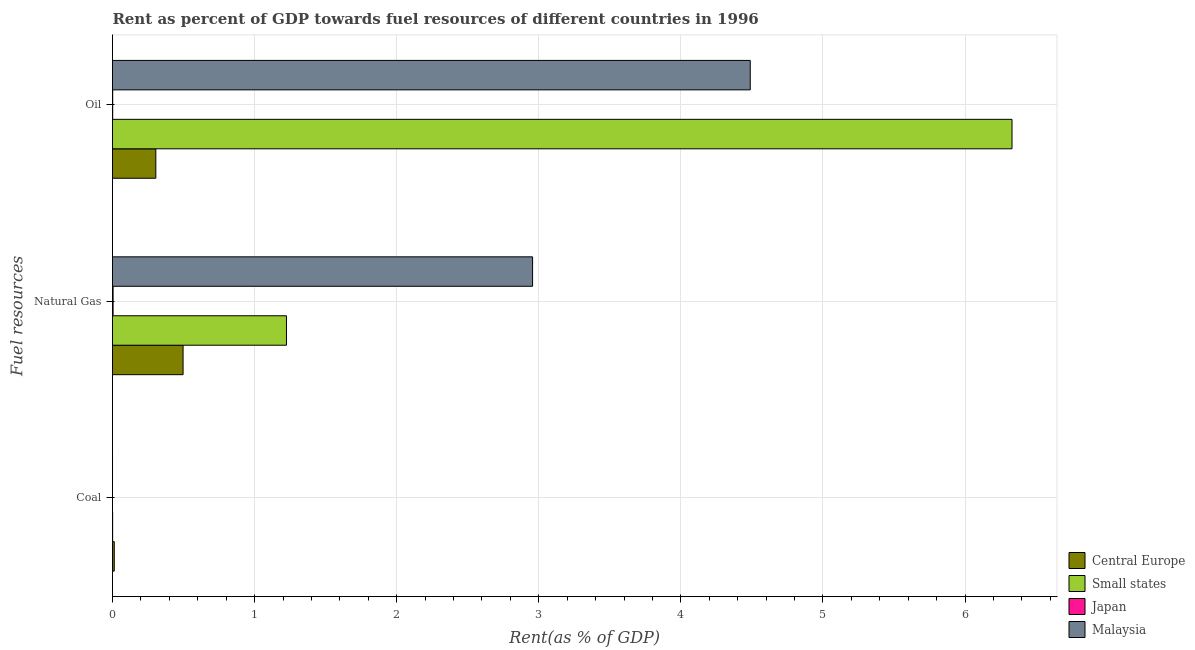How many different coloured bars are there?
Offer a very short reply. 4. How many groups of bars are there?
Provide a short and direct response. 3. Are the number of bars per tick equal to the number of legend labels?
Offer a very short reply. Yes. What is the label of the 2nd group of bars from the top?
Keep it short and to the point. Natural Gas. What is the rent towards natural gas in Japan?
Make the answer very short. 0. Across all countries, what is the maximum rent towards coal?
Your answer should be very brief. 0.01. Across all countries, what is the minimum rent towards coal?
Your response must be concise. 5.59419747539997e-7. In which country was the rent towards natural gas maximum?
Your answer should be very brief. Malaysia. What is the total rent towards oil in the graph?
Your answer should be compact. 11.13. What is the difference between the rent towards oil in Central Europe and that in Malaysia?
Keep it short and to the point. -4.18. What is the difference between the rent towards oil in Small states and the rent towards natural gas in Malaysia?
Offer a terse response. 3.37. What is the average rent towards natural gas per country?
Your answer should be very brief. 1.17. What is the difference between the rent towards coal and rent towards oil in Japan?
Offer a very short reply. -0. In how many countries, is the rent towards natural gas greater than 0.4 %?
Your answer should be very brief. 3. What is the ratio of the rent towards natural gas in Japan to that in Small states?
Provide a succinct answer. 0. What is the difference between the highest and the second highest rent towards natural gas?
Offer a terse response. 1.73. What is the difference between the highest and the lowest rent towards coal?
Provide a succinct answer. 0.01. What does the 3rd bar from the top in Natural Gas represents?
Your answer should be very brief. Small states. What does the 4th bar from the bottom in Natural Gas represents?
Give a very brief answer. Malaysia. How many countries are there in the graph?
Give a very brief answer. 4. Does the graph contain grids?
Make the answer very short. Yes. How many legend labels are there?
Your answer should be very brief. 4. What is the title of the graph?
Ensure brevity in your answer.  Rent as percent of GDP towards fuel resources of different countries in 1996. What is the label or title of the X-axis?
Your response must be concise. Rent(as % of GDP). What is the label or title of the Y-axis?
Ensure brevity in your answer.  Fuel resources. What is the Rent(as % of GDP) of Central Europe in Coal?
Provide a short and direct response. 0.01. What is the Rent(as % of GDP) of Small states in Coal?
Your response must be concise. 0. What is the Rent(as % of GDP) of Japan in Coal?
Ensure brevity in your answer.  5.59419747539997e-7. What is the Rent(as % of GDP) in Malaysia in Coal?
Offer a very short reply. 8.374194379820171e-5. What is the Rent(as % of GDP) in Central Europe in Natural Gas?
Offer a very short reply. 0.5. What is the Rent(as % of GDP) of Small states in Natural Gas?
Provide a short and direct response. 1.22. What is the Rent(as % of GDP) in Japan in Natural Gas?
Keep it short and to the point. 0. What is the Rent(as % of GDP) in Malaysia in Natural Gas?
Provide a succinct answer. 2.96. What is the Rent(as % of GDP) in Central Europe in Oil?
Provide a short and direct response. 0.3. What is the Rent(as % of GDP) of Small states in Oil?
Ensure brevity in your answer.  6.33. What is the Rent(as % of GDP) of Japan in Oil?
Ensure brevity in your answer.  0. What is the Rent(as % of GDP) of Malaysia in Oil?
Your response must be concise. 4.49. Across all Fuel resources, what is the maximum Rent(as % of GDP) in Central Europe?
Your response must be concise. 0.5. Across all Fuel resources, what is the maximum Rent(as % of GDP) of Small states?
Give a very brief answer. 6.33. Across all Fuel resources, what is the maximum Rent(as % of GDP) of Japan?
Offer a terse response. 0. Across all Fuel resources, what is the maximum Rent(as % of GDP) in Malaysia?
Keep it short and to the point. 4.49. Across all Fuel resources, what is the minimum Rent(as % of GDP) of Central Europe?
Keep it short and to the point. 0.01. Across all Fuel resources, what is the minimum Rent(as % of GDP) of Small states?
Give a very brief answer. 0. Across all Fuel resources, what is the minimum Rent(as % of GDP) in Japan?
Provide a short and direct response. 5.59419747539997e-7. Across all Fuel resources, what is the minimum Rent(as % of GDP) in Malaysia?
Give a very brief answer. 8.374194379820171e-5. What is the total Rent(as % of GDP) in Central Europe in the graph?
Ensure brevity in your answer.  0.81. What is the total Rent(as % of GDP) in Small states in the graph?
Give a very brief answer. 7.56. What is the total Rent(as % of GDP) of Japan in the graph?
Provide a short and direct response. 0.01. What is the total Rent(as % of GDP) in Malaysia in the graph?
Offer a terse response. 7.45. What is the difference between the Rent(as % of GDP) of Central Europe in Coal and that in Natural Gas?
Give a very brief answer. -0.48. What is the difference between the Rent(as % of GDP) in Small states in Coal and that in Natural Gas?
Your answer should be compact. -1.22. What is the difference between the Rent(as % of GDP) in Japan in Coal and that in Natural Gas?
Keep it short and to the point. -0. What is the difference between the Rent(as % of GDP) in Malaysia in Coal and that in Natural Gas?
Offer a terse response. -2.96. What is the difference between the Rent(as % of GDP) of Central Europe in Coal and that in Oil?
Keep it short and to the point. -0.29. What is the difference between the Rent(as % of GDP) in Small states in Coal and that in Oil?
Your response must be concise. -6.33. What is the difference between the Rent(as % of GDP) of Japan in Coal and that in Oil?
Ensure brevity in your answer.  -0. What is the difference between the Rent(as % of GDP) of Malaysia in Coal and that in Oil?
Provide a short and direct response. -4.49. What is the difference between the Rent(as % of GDP) in Central Europe in Natural Gas and that in Oil?
Offer a terse response. 0.19. What is the difference between the Rent(as % of GDP) of Small states in Natural Gas and that in Oil?
Offer a terse response. -5.11. What is the difference between the Rent(as % of GDP) of Japan in Natural Gas and that in Oil?
Your response must be concise. 0. What is the difference between the Rent(as % of GDP) of Malaysia in Natural Gas and that in Oil?
Ensure brevity in your answer.  -1.53. What is the difference between the Rent(as % of GDP) in Central Europe in Coal and the Rent(as % of GDP) in Small states in Natural Gas?
Provide a short and direct response. -1.21. What is the difference between the Rent(as % of GDP) of Central Europe in Coal and the Rent(as % of GDP) of Japan in Natural Gas?
Offer a very short reply. 0.01. What is the difference between the Rent(as % of GDP) in Central Europe in Coal and the Rent(as % of GDP) in Malaysia in Natural Gas?
Offer a terse response. -2.94. What is the difference between the Rent(as % of GDP) in Small states in Coal and the Rent(as % of GDP) in Japan in Natural Gas?
Your answer should be very brief. -0. What is the difference between the Rent(as % of GDP) in Small states in Coal and the Rent(as % of GDP) in Malaysia in Natural Gas?
Keep it short and to the point. -2.96. What is the difference between the Rent(as % of GDP) of Japan in Coal and the Rent(as % of GDP) of Malaysia in Natural Gas?
Your answer should be very brief. -2.96. What is the difference between the Rent(as % of GDP) in Central Europe in Coal and the Rent(as % of GDP) in Small states in Oil?
Offer a terse response. -6.32. What is the difference between the Rent(as % of GDP) of Central Europe in Coal and the Rent(as % of GDP) of Japan in Oil?
Make the answer very short. 0.01. What is the difference between the Rent(as % of GDP) of Central Europe in Coal and the Rent(as % of GDP) of Malaysia in Oil?
Provide a succinct answer. -4.48. What is the difference between the Rent(as % of GDP) of Small states in Coal and the Rent(as % of GDP) of Japan in Oil?
Provide a short and direct response. -0. What is the difference between the Rent(as % of GDP) of Small states in Coal and the Rent(as % of GDP) of Malaysia in Oil?
Ensure brevity in your answer.  -4.49. What is the difference between the Rent(as % of GDP) in Japan in Coal and the Rent(as % of GDP) in Malaysia in Oil?
Offer a terse response. -4.49. What is the difference between the Rent(as % of GDP) in Central Europe in Natural Gas and the Rent(as % of GDP) in Small states in Oil?
Provide a succinct answer. -5.83. What is the difference between the Rent(as % of GDP) of Central Europe in Natural Gas and the Rent(as % of GDP) of Japan in Oil?
Make the answer very short. 0.5. What is the difference between the Rent(as % of GDP) of Central Europe in Natural Gas and the Rent(as % of GDP) of Malaysia in Oil?
Provide a succinct answer. -3.99. What is the difference between the Rent(as % of GDP) in Small states in Natural Gas and the Rent(as % of GDP) in Japan in Oil?
Your response must be concise. 1.22. What is the difference between the Rent(as % of GDP) of Small states in Natural Gas and the Rent(as % of GDP) of Malaysia in Oil?
Your response must be concise. -3.26. What is the difference between the Rent(as % of GDP) of Japan in Natural Gas and the Rent(as % of GDP) of Malaysia in Oil?
Give a very brief answer. -4.48. What is the average Rent(as % of GDP) in Central Europe per Fuel resources?
Offer a terse response. 0.27. What is the average Rent(as % of GDP) of Small states per Fuel resources?
Make the answer very short. 2.52. What is the average Rent(as % of GDP) of Japan per Fuel resources?
Your answer should be compact. 0. What is the average Rent(as % of GDP) of Malaysia per Fuel resources?
Your answer should be very brief. 2.48. What is the difference between the Rent(as % of GDP) of Central Europe and Rent(as % of GDP) of Small states in Coal?
Your answer should be very brief. 0.01. What is the difference between the Rent(as % of GDP) of Central Europe and Rent(as % of GDP) of Japan in Coal?
Provide a short and direct response. 0.01. What is the difference between the Rent(as % of GDP) in Central Europe and Rent(as % of GDP) in Malaysia in Coal?
Your answer should be compact. 0.01. What is the difference between the Rent(as % of GDP) in Small states and Rent(as % of GDP) in Japan in Coal?
Keep it short and to the point. 0. What is the difference between the Rent(as % of GDP) in Small states and Rent(as % of GDP) in Malaysia in Coal?
Offer a terse response. 0. What is the difference between the Rent(as % of GDP) in Japan and Rent(as % of GDP) in Malaysia in Coal?
Give a very brief answer. -0. What is the difference between the Rent(as % of GDP) of Central Europe and Rent(as % of GDP) of Small states in Natural Gas?
Your answer should be compact. -0.73. What is the difference between the Rent(as % of GDP) of Central Europe and Rent(as % of GDP) of Japan in Natural Gas?
Offer a very short reply. 0.49. What is the difference between the Rent(as % of GDP) in Central Europe and Rent(as % of GDP) in Malaysia in Natural Gas?
Your answer should be compact. -2.46. What is the difference between the Rent(as % of GDP) in Small states and Rent(as % of GDP) in Japan in Natural Gas?
Offer a very short reply. 1.22. What is the difference between the Rent(as % of GDP) in Small states and Rent(as % of GDP) in Malaysia in Natural Gas?
Provide a succinct answer. -1.73. What is the difference between the Rent(as % of GDP) of Japan and Rent(as % of GDP) of Malaysia in Natural Gas?
Keep it short and to the point. -2.95. What is the difference between the Rent(as % of GDP) of Central Europe and Rent(as % of GDP) of Small states in Oil?
Give a very brief answer. -6.03. What is the difference between the Rent(as % of GDP) of Central Europe and Rent(as % of GDP) of Japan in Oil?
Make the answer very short. 0.3. What is the difference between the Rent(as % of GDP) in Central Europe and Rent(as % of GDP) in Malaysia in Oil?
Your answer should be compact. -4.18. What is the difference between the Rent(as % of GDP) in Small states and Rent(as % of GDP) in Japan in Oil?
Your answer should be compact. 6.33. What is the difference between the Rent(as % of GDP) of Small states and Rent(as % of GDP) of Malaysia in Oil?
Make the answer very short. 1.84. What is the difference between the Rent(as % of GDP) in Japan and Rent(as % of GDP) in Malaysia in Oil?
Ensure brevity in your answer.  -4.49. What is the ratio of the Rent(as % of GDP) of Central Europe in Coal to that in Natural Gas?
Provide a short and direct response. 0.03. What is the ratio of the Rent(as % of GDP) of Small states in Coal to that in Natural Gas?
Make the answer very short. 0. What is the ratio of the Rent(as % of GDP) of Central Europe in Coal to that in Oil?
Provide a succinct answer. 0.04. What is the ratio of the Rent(as % of GDP) of Japan in Coal to that in Oil?
Offer a terse response. 0. What is the ratio of the Rent(as % of GDP) in Central Europe in Natural Gas to that in Oil?
Provide a short and direct response. 1.63. What is the ratio of the Rent(as % of GDP) of Small states in Natural Gas to that in Oil?
Provide a short and direct response. 0.19. What is the ratio of the Rent(as % of GDP) of Japan in Natural Gas to that in Oil?
Provide a short and direct response. 3.02. What is the ratio of the Rent(as % of GDP) of Malaysia in Natural Gas to that in Oil?
Keep it short and to the point. 0.66. What is the difference between the highest and the second highest Rent(as % of GDP) of Central Europe?
Provide a succinct answer. 0.19. What is the difference between the highest and the second highest Rent(as % of GDP) in Small states?
Offer a very short reply. 5.11. What is the difference between the highest and the second highest Rent(as % of GDP) in Japan?
Make the answer very short. 0. What is the difference between the highest and the second highest Rent(as % of GDP) of Malaysia?
Give a very brief answer. 1.53. What is the difference between the highest and the lowest Rent(as % of GDP) of Central Europe?
Offer a very short reply. 0.48. What is the difference between the highest and the lowest Rent(as % of GDP) in Small states?
Give a very brief answer. 6.33. What is the difference between the highest and the lowest Rent(as % of GDP) in Japan?
Offer a terse response. 0. What is the difference between the highest and the lowest Rent(as % of GDP) in Malaysia?
Make the answer very short. 4.49. 